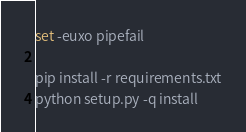<code> <loc_0><loc_0><loc_500><loc_500><_Bash_>set -euxo pipefail

pip install -r requirements.txt
python setup.py -q install</code> 